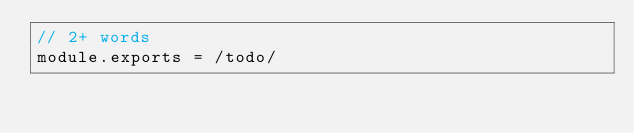Convert code to text. <code><loc_0><loc_0><loc_500><loc_500><_JavaScript_>// 2+ words
module.exports = /todo/
</code> 